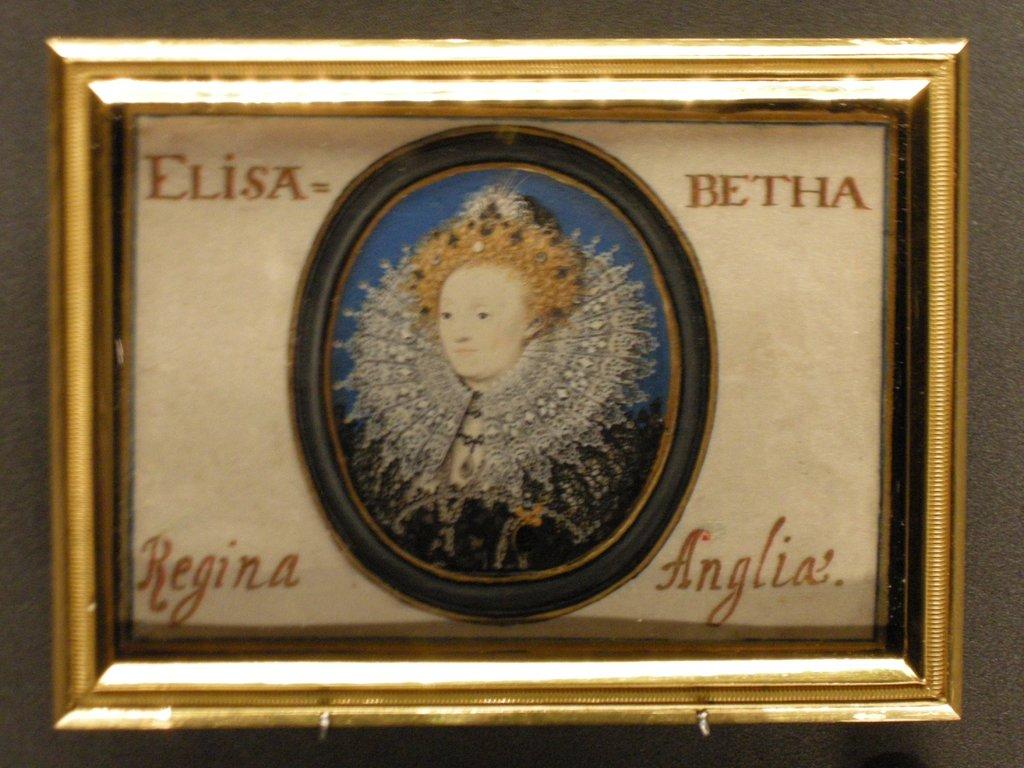What name is on the top right?
Offer a very short reply. Betha. What name is on the bottom left?
Offer a very short reply. Regina. 